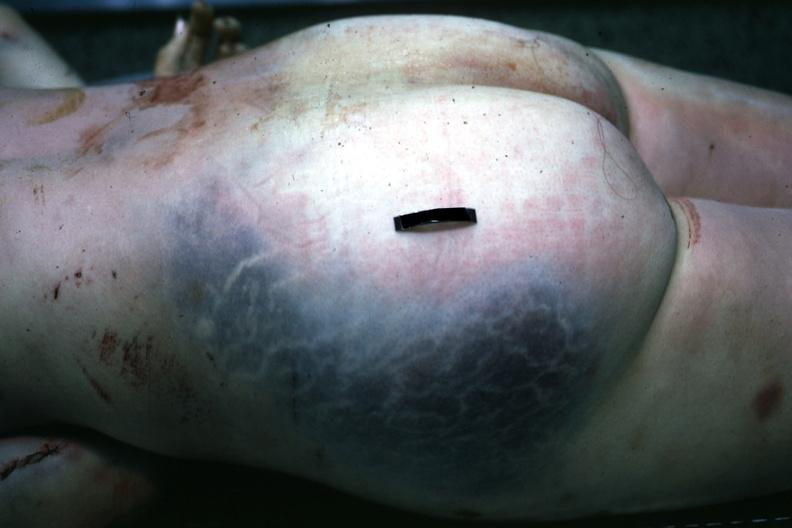what is present?
Answer the question using a single word or phrase. Soft tissue 